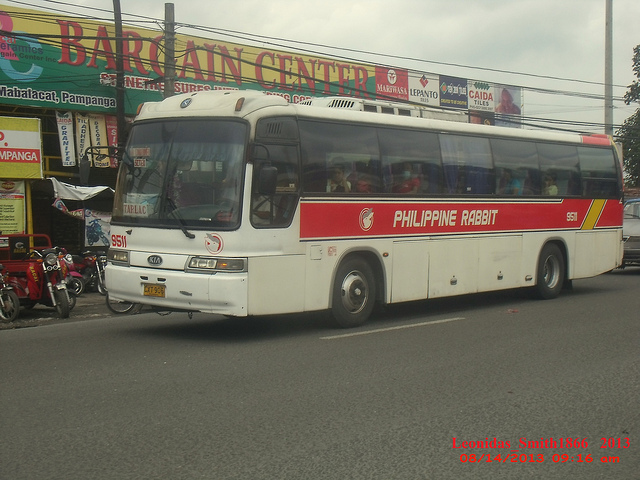Identify the text contained in this image. PHILIPPINE RABBIT 8511 TNP LLC Pampanga am 09 2013 24 2013 KIA abalacat' MPANGA DACOFA GRANITE TILES CAIDA LEPANTO CENTER 